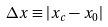<formula> <loc_0><loc_0><loc_500><loc_500>\Delta x \equiv | x _ { c } - x _ { 0 } |</formula> 